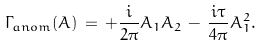Convert formula to latex. <formula><loc_0><loc_0><loc_500><loc_500>\Gamma _ { a n o m } ( A ) \, = \, + \frac { i } { 2 \pi } A _ { 1 } A _ { 2 } \, - \, \frac { i \tau } { 4 \pi } A _ { 1 } ^ { 2 } .</formula> 